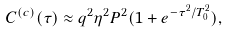Convert formula to latex. <formula><loc_0><loc_0><loc_500><loc_500>C ^ { ( c ) } ( \tau ) \approx q ^ { 2 } \eta ^ { 2 } P ^ { 2 } ( 1 + e ^ { - \tau ^ { 2 } / T _ { 0 } ^ { 2 } } ) ,</formula> 